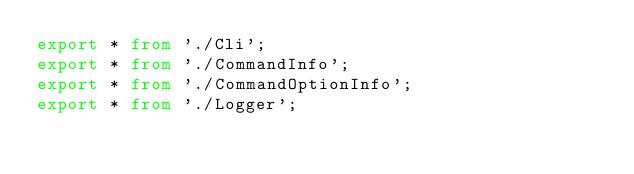Convert code to text. <code><loc_0><loc_0><loc_500><loc_500><_TypeScript_>export * from './Cli';
export * from './CommandInfo';
export * from './CommandOptionInfo';
export * from './Logger';

</code> 